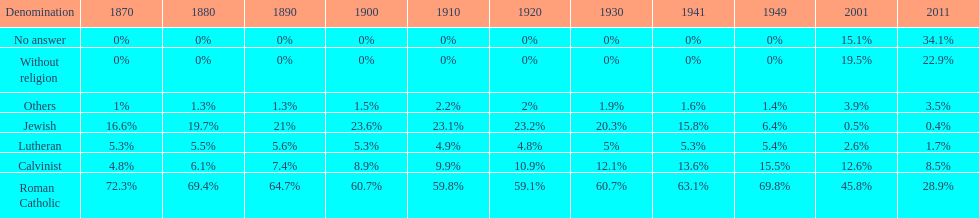Which denomination held the largest percentage in 1880? Roman Catholic. Would you be able to parse every entry in this table? {'header': ['Denomination', '1870', '1880', '1890', '1900', '1910', '1920', '1930', '1941', '1949', '2001', '2011'], 'rows': [['No answer', '0%', '0%', '0%', '0%', '0%', '0%', '0%', '0%', '0%', '15.1%', '34.1%'], ['Without religion', '0%', '0%', '0%', '0%', '0%', '0%', '0%', '0%', '0%', '19.5%', '22.9%'], ['Others', '1%', '1.3%', '1.3%', '1.5%', '2.2%', '2%', '1.9%', '1.6%', '1.4%', '3.9%', '3.5%'], ['Jewish', '16.6%', '19.7%', '21%', '23.6%', '23.1%', '23.2%', '20.3%', '15.8%', '6.4%', '0.5%', '0.4%'], ['Lutheran', '5.3%', '5.5%', '5.6%', '5.3%', '4.9%', '4.8%', '5%', '5.3%', '5.4%', '2.6%', '1.7%'], ['Calvinist', '4.8%', '6.1%', '7.4%', '8.9%', '9.9%', '10.9%', '12.1%', '13.6%', '15.5%', '12.6%', '8.5%'], ['Roman Catholic', '72.3%', '69.4%', '64.7%', '60.7%', '59.8%', '59.1%', '60.7%', '63.1%', '69.8%', '45.8%', '28.9%']]} 